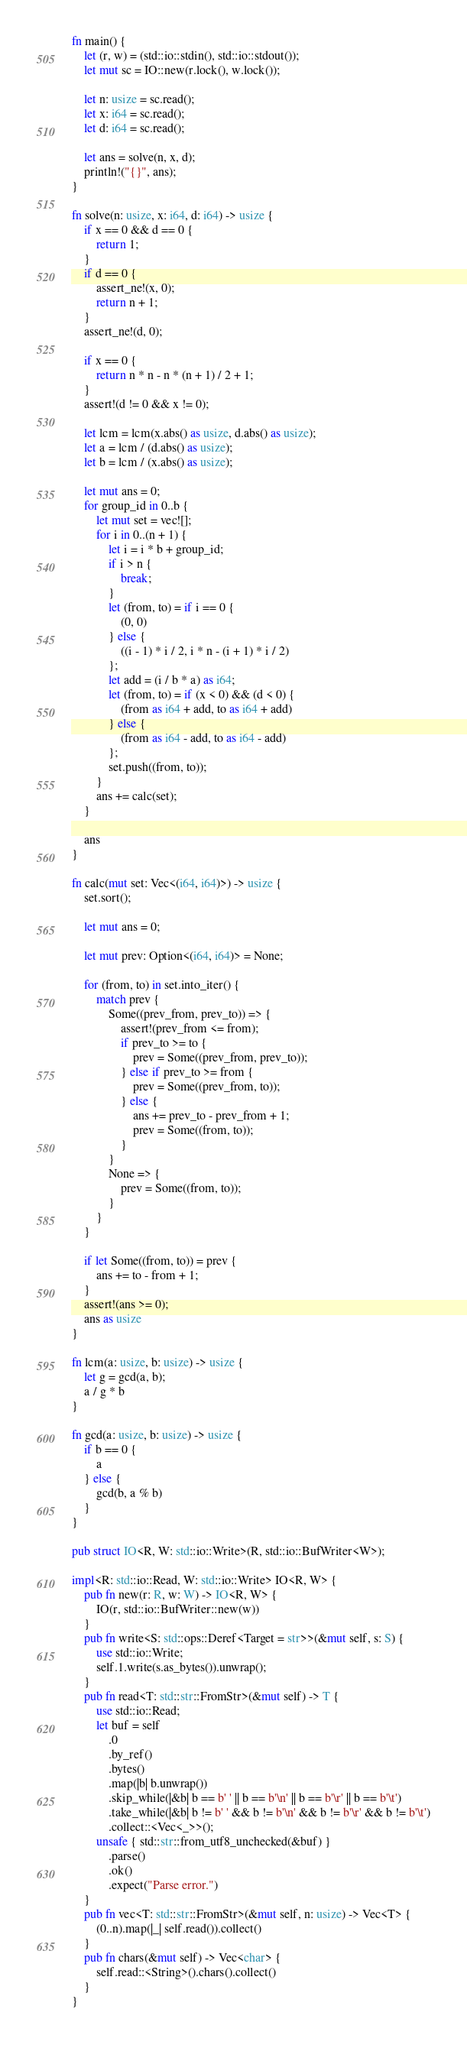Convert code to text. <code><loc_0><loc_0><loc_500><loc_500><_Rust_>fn main() {
    let (r, w) = (std::io::stdin(), std::io::stdout());
    let mut sc = IO::new(r.lock(), w.lock());

    let n: usize = sc.read();
    let x: i64 = sc.read();
    let d: i64 = sc.read();

    let ans = solve(n, x, d);
    println!("{}", ans);
}

fn solve(n: usize, x: i64, d: i64) -> usize {
    if x == 0 && d == 0 {
        return 1;
    }
    if d == 0 {
        assert_ne!(x, 0);
        return n + 1;
    }
    assert_ne!(d, 0);

    if x == 0 {
        return n * n - n * (n + 1) / 2 + 1;
    }
    assert!(d != 0 && x != 0);

    let lcm = lcm(x.abs() as usize, d.abs() as usize);
    let a = lcm / (d.abs() as usize);
    let b = lcm / (x.abs() as usize);

    let mut ans = 0;
    for group_id in 0..b {
        let mut set = vec![];
        for i in 0..(n + 1) {
            let i = i * b + group_id;
            if i > n {
                break;
            }
            let (from, to) = if i == 0 {
                (0, 0)
            } else {
                ((i - 1) * i / 2, i * n - (i + 1) * i / 2)
            };
            let add = (i / b * a) as i64;
            let (from, to) = if (x < 0) && (d < 0) {
                (from as i64 + add, to as i64 + add)
            } else {
                (from as i64 - add, to as i64 - add)
            };
            set.push((from, to));
        }
        ans += calc(set);
    }

    ans
}

fn calc(mut set: Vec<(i64, i64)>) -> usize {
    set.sort();

    let mut ans = 0;

    let mut prev: Option<(i64, i64)> = None;

    for (from, to) in set.into_iter() {
        match prev {
            Some((prev_from, prev_to)) => {
                assert!(prev_from <= from);
                if prev_to >= to {
                    prev = Some((prev_from, prev_to));
                } else if prev_to >= from {
                    prev = Some((prev_from, to));
                } else {
                    ans += prev_to - prev_from + 1;
                    prev = Some((from, to));
                }
            }
            None => {
                prev = Some((from, to));
            }
        }
    }

    if let Some((from, to)) = prev {
        ans += to - from + 1;
    }
    assert!(ans >= 0);
    ans as usize
}

fn lcm(a: usize, b: usize) -> usize {
    let g = gcd(a, b);
    a / g * b
}

fn gcd(a: usize, b: usize) -> usize {
    if b == 0 {
        a
    } else {
        gcd(b, a % b)
    }
}

pub struct IO<R, W: std::io::Write>(R, std::io::BufWriter<W>);

impl<R: std::io::Read, W: std::io::Write> IO<R, W> {
    pub fn new(r: R, w: W) -> IO<R, W> {
        IO(r, std::io::BufWriter::new(w))
    }
    pub fn write<S: std::ops::Deref<Target = str>>(&mut self, s: S) {
        use std::io::Write;
        self.1.write(s.as_bytes()).unwrap();
    }
    pub fn read<T: std::str::FromStr>(&mut self) -> T {
        use std::io::Read;
        let buf = self
            .0
            .by_ref()
            .bytes()
            .map(|b| b.unwrap())
            .skip_while(|&b| b == b' ' || b == b'\n' || b == b'\r' || b == b'\t')
            .take_while(|&b| b != b' ' && b != b'\n' && b != b'\r' && b != b'\t')
            .collect::<Vec<_>>();
        unsafe { std::str::from_utf8_unchecked(&buf) }
            .parse()
            .ok()
            .expect("Parse error.")
    }
    pub fn vec<T: std::str::FromStr>(&mut self, n: usize) -> Vec<T> {
        (0..n).map(|_| self.read()).collect()
    }
    pub fn chars(&mut self) -> Vec<char> {
        self.read::<String>().chars().collect()
    }
}
</code> 